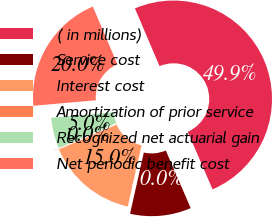<chart> <loc_0><loc_0><loc_500><loc_500><pie_chart><fcel>( in millions)<fcel>Service cost<fcel>Interest cost<fcel>Amortization of prior service<fcel>Recognized net actuarial gain<fcel>Net periodic benefit cost<nl><fcel>49.93%<fcel>10.01%<fcel>15.0%<fcel>0.04%<fcel>5.03%<fcel>19.99%<nl></chart> 